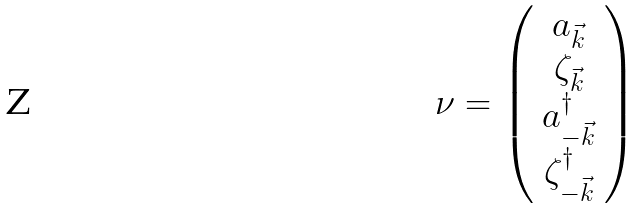Convert formula to latex. <formula><loc_0><loc_0><loc_500><loc_500>\nu = \left ( \begin{array} { c } a _ { \vec { k } } \\ \zeta _ { \vec { k } } \\ a _ { - \vec { k } } ^ { \dagger } \\ \zeta _ { - \vec { k } } ^ { \dagger } \end{array} \right )</formula> 